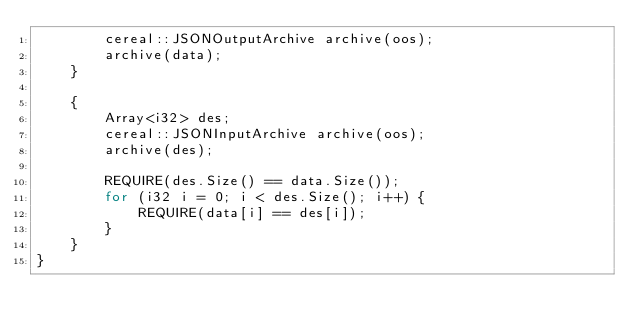Convert code to text. <code><loc_0><loc_0><loc_500><loc_500><_C++_>		cereal::JSONOutputArchive archive(oos);
		archive(data);
	}

	{
		Array<i32> des;
		cereal::JSONInputArchive archive(oos);
		archive(des);

		REQUIRE(des.Size() == data.Size());
		for (i32 i = 0; i < des.Size(); i++) {
			REQUIRE(data[i] == des[i]);
		}
	}
}</code> 